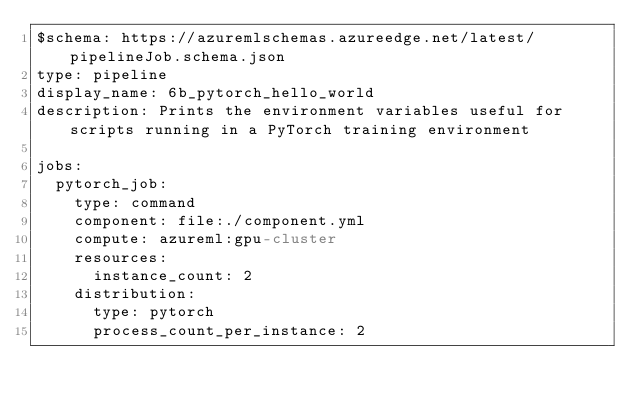Convert code to text. <code><loc_0><loc_0><loc_500><loc_500><_YAML_>$schema: https://azuremlschemas.azureedge.net/latest/pipelineJob.schema.json
type: pipeline
display_name: 6b_pytorch_hello_world
description: Prints the environment variables useful for scripts running in a PyTorch training environment

jobs:
  pytorch_job:
    type: command
    component: file:./component.yml
    compute: azureml:gpu-cluster
    resources:
      instance_count: 2
    distribution:
      type: pytorch
      process_count_per_instance: 2

        
</code> 